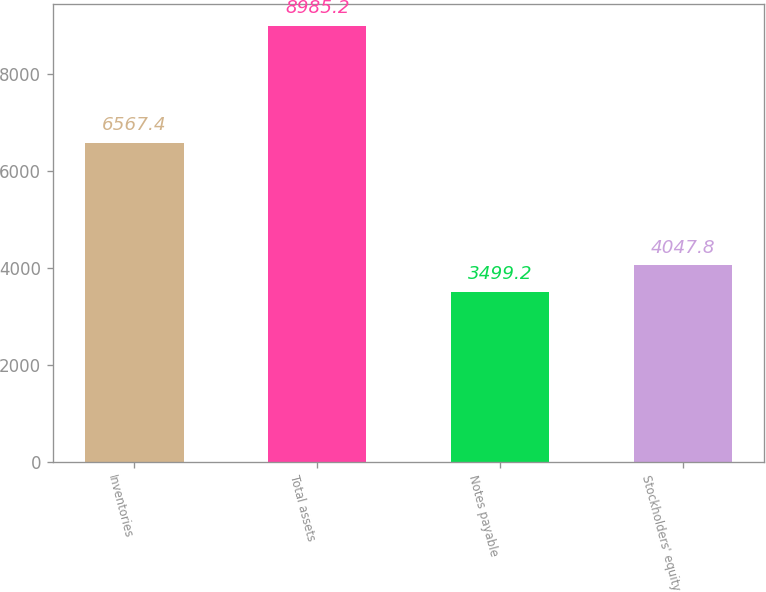Convert chart to OTSL. <chart><loc_0><loc_0><loc_500><loc_500><bar_chart><fcel>Inventories<fcel>Total assets<fcel>Notes payable<fcel>Stockholders' equity<nl><fcel>6567.4<fcel>8985.2<fcel>3499.2<fcel>4047.8<nl></chart> 